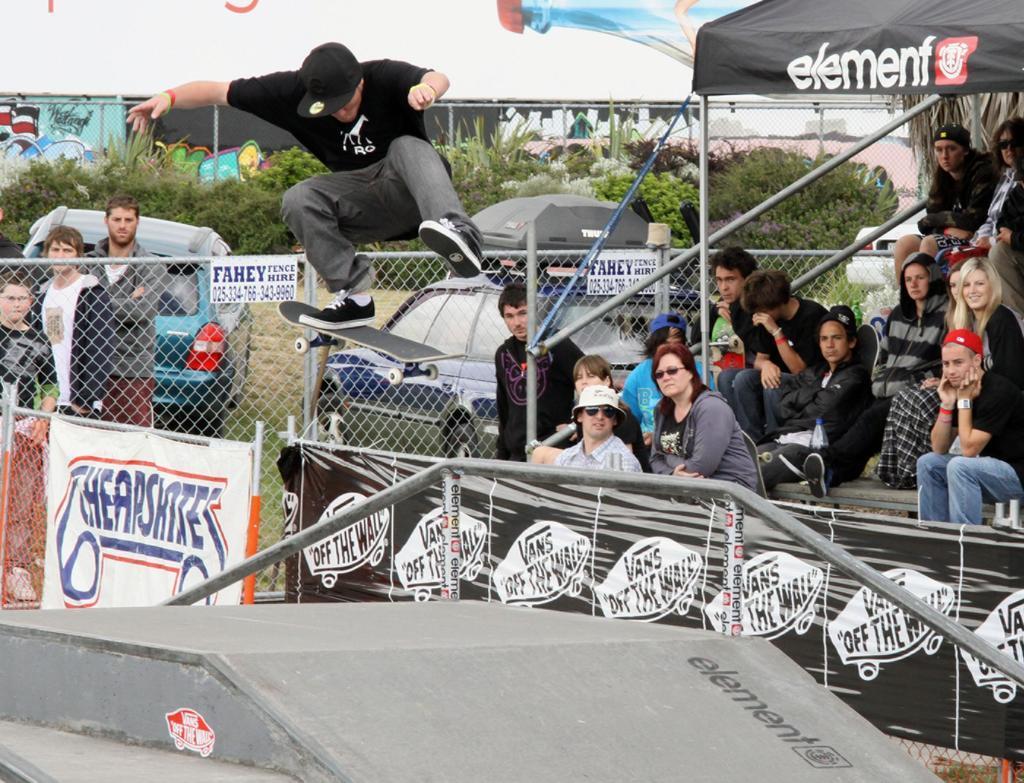How would you summarize this image in a sentence or two? On the right side of the image there is a tent and we can see people sitting. At the bottom we can see a ramp. In the center there is a man jumping on the skating board. There is a mesh and a board. In the background there are people, cars, trees and a shed. 